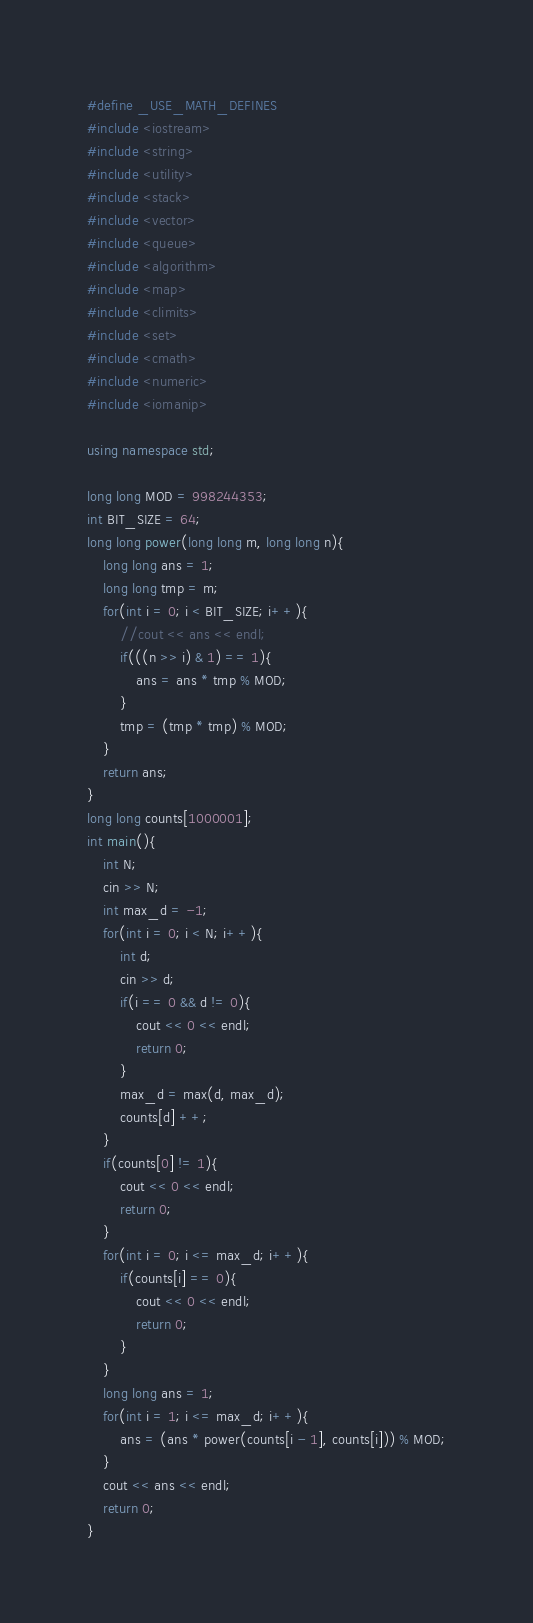<code> <loc_0><loc_0><loc_500><loc_500><_C++_>#define _USE_MATH_DEFINES
#include <iostream>
#include <string>
#include <utility>
#include <stack>
#include <vector>
#include <queue>
#include <algorithm>
#include <map>
#include <climits>
#include <set>
#include <cmath>
#include <numeric>
#include <iomanip>

using namespace std;

long long MOD = 998244353;
int BIT_SIZE = 64;
long long power(long long m, long long n){
    long long ans = 1;
    long long tmp = m;
    for(int i = 0; i < BIT_SIZE; i++){
        //cout << ans << endl;
        if(((n >> i) & 1) == 1){
            ans = ans * tmp % MOD;
        }
        tmp = (tmp * tmp) % MOD;
    }
    return ans;
}
long long counts[1000001];
int main(){ 
    int N;
    cin >> N;
    int max_d = -1;
    for(int i = 0; i < N; i++){
        int d;
        cin >> d;
        if(i == 0 && d != 0){
            cout << 0 << endl;
            return 0;
        }
        max_d = max(d, max_d);
        counts[d] ++;
    }
    if(counts[0] != 1){
        cout << 0 << endl;
        return 0;
    }
    for(int i = 0; i <= max_d; i++){
        if(counts[i] == 0){
            cout << 0 << endl;
            return 0;
        }
    }
    long long ans = 1;
    for(int i = 1; i <= max_d; i++){
        ans = (ans * power(counts[i - 1], counts[i])) % MOD;
    }
    cout << ans << endl;
    return 0;
}
</code> 